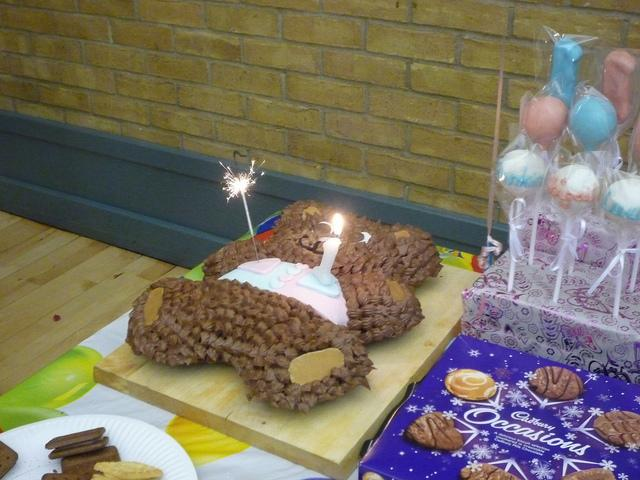What is the cake in the shape of? Please explain your reasoning. bear. The cake looks like a teddy bear. 